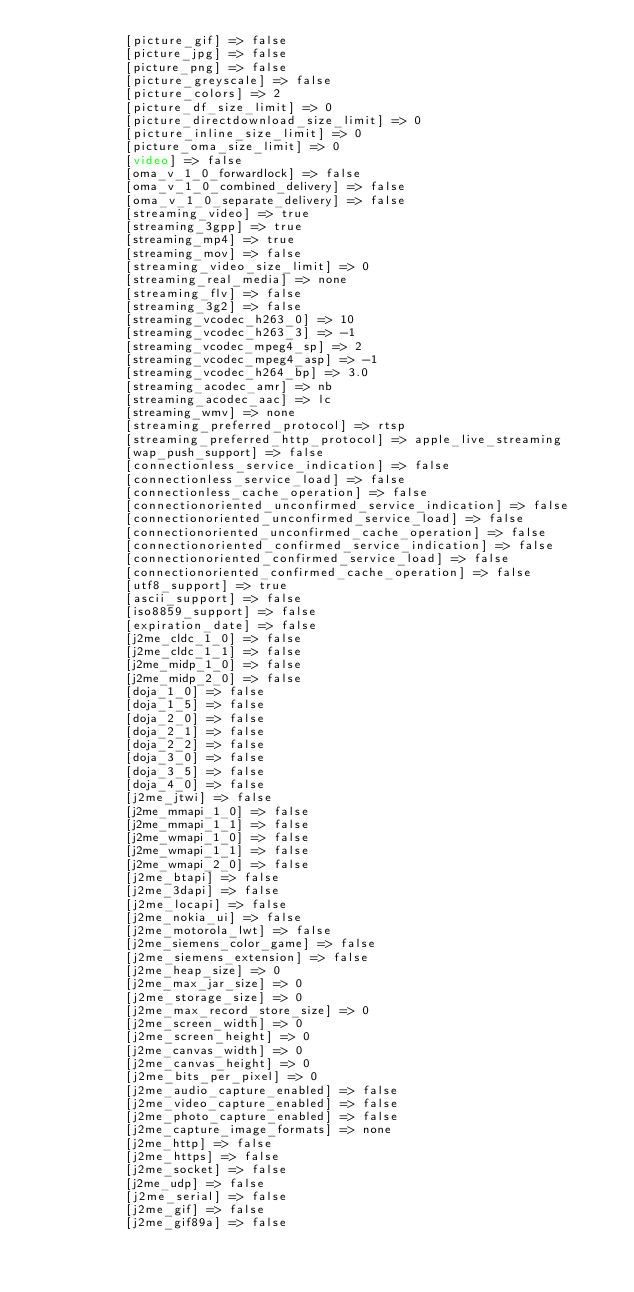Convert code to text. <code><loc_0><loc_0><loc_500><loc_500><_HTML_>            [picture_gif] => false
            [picture_jpg] => false
            [picture_png] => false
            [picture_greyscale] => false
            [picture_colors] => 2
            [picture_df_size_limit] => 0
            [picture_directdownload_size_limit] => 0
            [picture_inline_size_limit] => 0
            [picture_oma_size_limit] => 0
            [video] => false
            [oma_v_1_0_forwardlock] => false
            [oma_v_1_0_combined_delivery] => false
            [oma_v_1_0_separate_delivery] => false
            [streaming_video] => true
            [streaming_3gpp] => true
            [streaming_mp4] => true
            [streaming_mov] => false
            [streaming_video_size_limit] => 0
            [streaming_real_media] => none
            [streaming_flv] => false
            [streaming_3g2] => false
            [streaming_vcodec_h263_0] => 10
            [streaming_vcodec_h263_3] => -1
            [streaming_vcodec_mpeg4_sp] => 2
            [streaming_vcodec_mpeg4_asp] => -1
            [streaming_vcodec_h264_bp] => 3.0
            [streaming_acodec_amr] => nb
            [streaming_acodec_aac] => lc
            [streaming_wmv] => none
            [streaming_preferred_protocol] => rtsp
            [streaming_preferred_http_protocol] => apple_live_streaming
            [wap_push_support] => false
            [connectionless_service_indication] => false
            [connectionless_service_load] => false
            [connectionless_cache_operation] => false
            [connectionoriented_unconfirmed_service_indication] => false
            [connectionoriented_unconfirmed_service_load] => false
            [connectionoriented_unconfirmed_cache_operation] => false
            [connectionoriented_confirmed_service_indication] => false
            [connectionoriented_confirmed_service_load] => false
            [connectionoriented_confirmed_cache_operation] => false
            [utf8_support] => true
            [ascii_support] => false
            [iso8859_support] => false
            [expiration_date] => false
            [j2me_cldc_1_0] => false
            [j2me_cldc_1_1] => false
            [j2me_midp_1_0] => false
            [j2me_midp_2_0] => false
            [doja_1_0] => false
            [doja_1_5] => false
            [doja_2_0] => false
            [doja_2_1] => false
            [doja_2_2] => false
            [doja_3_0] => false
            [doja_3_5] => false
            [doja_4_0] => false
            [j2me_jtwi] => false
            [j2me_mmapi_1_0] => false
            [j2me_mmapi_1_1] => false
            [j2me_wmapi_1_0] => false
            [j2me_wmapi_1_1] => false
            [j2me_wmapi_2_0] => false
            [j2me_btapi] => false
            [j2me_3dapi] => false
            [j2me_locapi] => false
            [j2me_nokia_ui] => false
            [j2me_motorola_lwt] => false
            [j2me_siemens_color_game] => false
            [j2me_siemens_extension] => false
            [j2me_heap_size] => 0
            [j2me_max_jar_size] => 0
            [j2me_storage_size] => 0
            [j2me_max_record_store_size] => 0
            [j2me_screen_width] => 0
            [j2me_screen_height] => 0
            [j2me_canvas_width] => 0
            [j2me_canvas_height] => 0
            [j2me_bits_per_pixel] => 0
            [j2me_audio_capture_enabled] => false
            [j2me_video_capture_enabled] => false
            [j2me_photo_capture_enabled] => false
            [j2me_capture_image_formats] => none
            [j2me_http] => false
            [j2me_https] => false
            [j2me_socket] => false
            [j2me_udp] => false
            [j2me_serial] => false
            [j2me_gif] => false
            [j2me_gif89a] => false</code> 